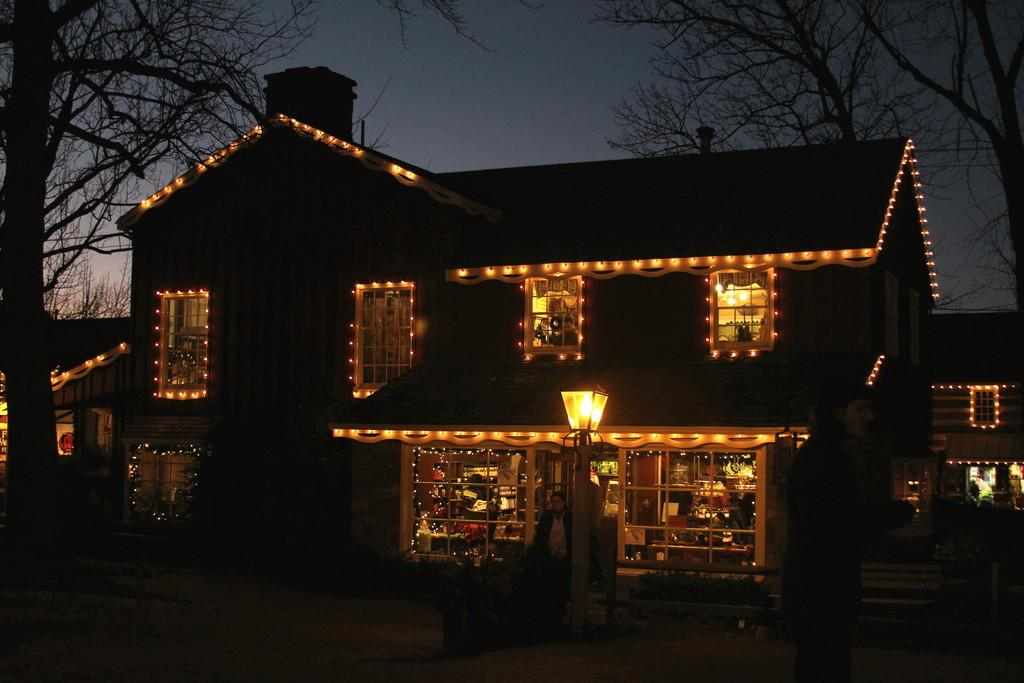What type of structure is present in the image? There is a house in the image. What can be seen illuminating the scene in the image? There are many lights visible in the image. What type of vegetation is present on both sides of the image? There are trees on the left side and the right side of the image. What is visible at the top of the image? The sky is visible at the top of the image. Can you describe the person in the image? There is a person in the front of the image. How many ducks are swimming in the silver pond in the image? There are no ducks or silver pond present in the image. What type of wave is visible in the image? There is no wave visible in the image. 